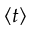Convert formula to latex. <formula><loc_0><loc_0><loc_500><loc_500>\langle t \rangle</formula> 